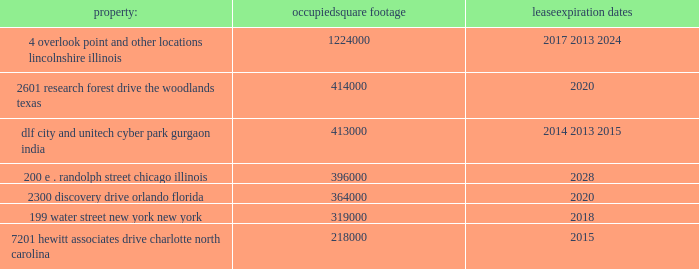Class a ordinary shares of aon plc are , at present , eligible for deposit and clearing within the dtc system .
In connection with the closing of the merger , we entered into arrangements with dtc whereby we agreed to indemnify dtc for any stamp duty and/or sdrt that may be assessed upon it as a result of its service as a depository and clearing agency for our class a ordinary shares .
In addition , we have obtained a ruling from hmrc in respect of the stamp duty and sdrt consequences of the reorganization , and sdrt has been paid in accordance with the terms of this ruling in respect of the deposit of class a ordinary shares with the initial depository .
Dtc will generally have discretion to cease to act as a depository and clearing agency for the class a ordinary shares .
If dtc determines at any time that the class a ordinary shares are not eligible for continued deposit and clearance within its facilities , then we believe the class a ordinary shares would not be eligible for continued listing on a u.s .
Securities exchange or inclusion in the s&p 500 and trading in the class a ordinary shares would be disrupted .
While we would pursue alternative arrangements to preserve our listing and maintain trading , any such disruption could have a material adverse effect on the trading price of the class a ordinary shares .
Item 1b .
Unresolved staff comments .
Item 2 .
Properties .
We have offices in various locations throughout the world .
Substantially all of our offices are located in leased premises .
We maintain our corporate headquarters at 8 devonshire square , london , england , where we occupy approximately 225000 square feet of space under an operating lease agreement that expires in 2018 .
We own one building at pallbergweg 2-4 , amsterdam , the netherlands ( 150000 square feet ) .
The following are additional significant leased properties , along with the occupied square footage and expiration .
Property : occupied square footage expiration .
The locations in lincolnshire , illinois , the woodlands , texas , gurgaon , india , orlando , florida , and charlotte , north carolina , each of which were acquired as part of the hewitt acquisition in 2010 , are primarily dedicated to our hr solutions segment .
The other locations listed above house personnel from both of our reportable segments .
In november 2011 , aon entered into an agreement to lease 190000 square feet in a new building to be constructed in london , united kingdom .
The agreement is contingent upon the completion of the building construction .
Aon expects to move into the new building in 2015 when it exercises an early break option at the devonshire square location .
In september 2013 , aon entered into an agreement to lease up to 479000 square feet in a new building to be constructed in gurgaon , india .
The agreement is contingent upon the completion of the building construction .
Aon expects to move into the new building in phases during 2014 and 2015 upon the expiration of the existing leases at the gurgaon locations .
In general , no difficulty is anticipated in negotiating renewals as leases expire or in finding other satisfactory space if the premises become unavailable .
We believe that the facilities we currently occupy are adequate for the purposes for which they are being used and are well maintained .
In certain circumstances , we may have unused space and may seek to sublet such space to third parties , depending upon the demands for office space in the locations involved .
See note 9 "lease commitments" of the notes to consolidated financial statements in part ii , item 8 of this report for information with respect to our lease commitments as of december 31 , 2013 .
Item 3 .
Legal proceedings .
We hereby incorporate by reference note 16 "commitments and contingencies" of the notes to consolidated financial statements in part ii , item 8 of this report. .
What is the total square feet of new building to be constructed where aon is expected to move in? 
Computations: (190000 + 479000)
Answer: 669000.0. 